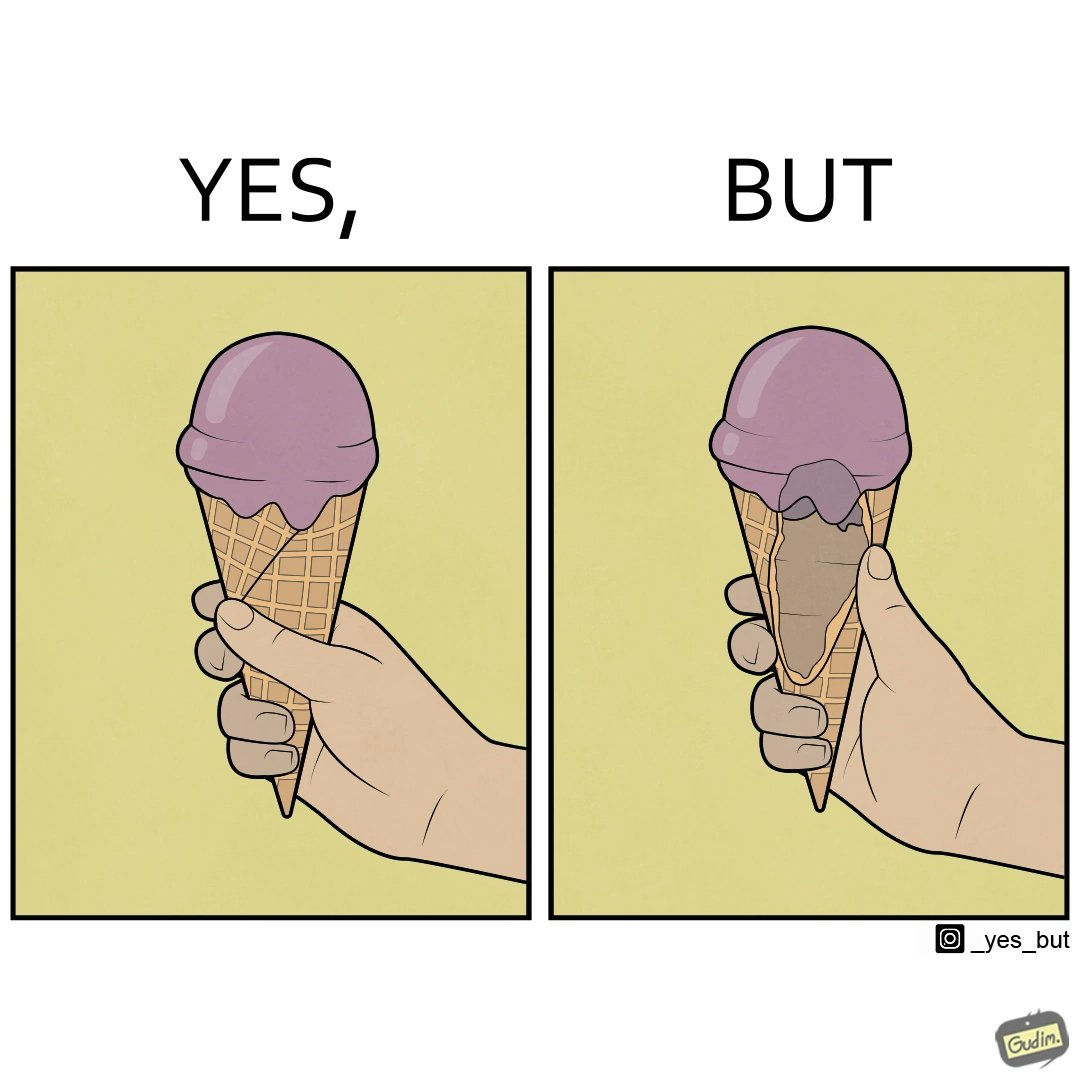Is this image satirical or non-satirical? Yes, this image is satirical. 